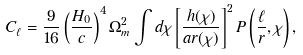<formula> <loc_0><loc_0><loc_500><loc_500>C _ { \ell } = \frac { 9 } { 1 6 } \left ( \frac { H _ { 0 } } { c } \right ) ^ { 4 } \Omega _ { m } ^ { 2 } \int d \chi \left [ \frac { h ( \chi ) } { a r ( \chi ) } \right ] ^ { 2 } P \left ( \frac { \ell } { r } , \chi \right ) ,</formula> 